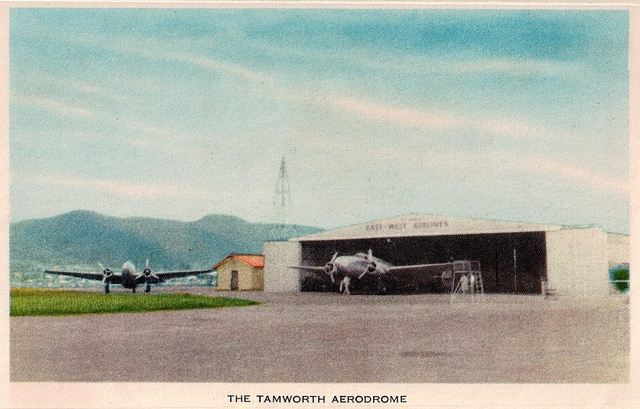Describe the objects in this image and their specific colors. I can see airplane in beige, black, gray, and darkgray tones, airplane in beige, black, darkgray, and gray tones, people in beige, gray, darkgray, and black tones, and people in beige, gray, and black tones in this image. 